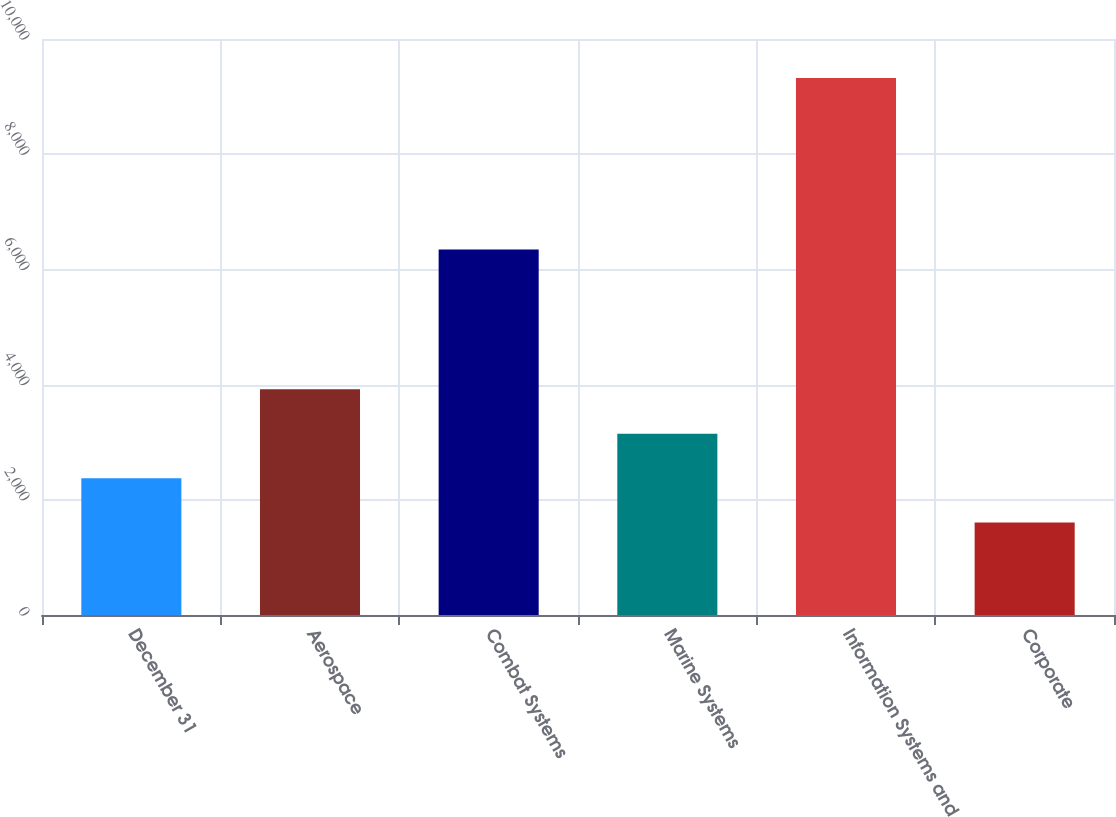Convert chart to OTSL. <chart><loc_0><loc_0><loc_500><loc_500><bar_chart><fcel>December 31<fcel>Aerospace<fcel>Combat Systems<fcel>Marine Systems<fcel>Information Systems and<fcel>Corporate<nl><fcel>2375.9<fcel>3919.7<fcel>6347<fcel>3147.8<fcel>9323<fcel>1604<nl></chart> 